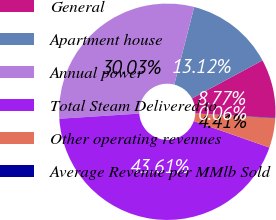Convert chart to OTSL. <chart><loc_0><loc_0><loc_500><loc_500><pie_chart><fcel>General<fcel>Apartment house<fcel>Annual power<fcel>Total Steam Delivered to<fcel>Other operating revenues<fcel>Average Revenue per MMlb Sold<nl><fcel>8.77%<fcel>13.12%<fcel>30.03%<fcel>43.61%<fcel>4.41%<fcel>0.06%<nl></chart> 